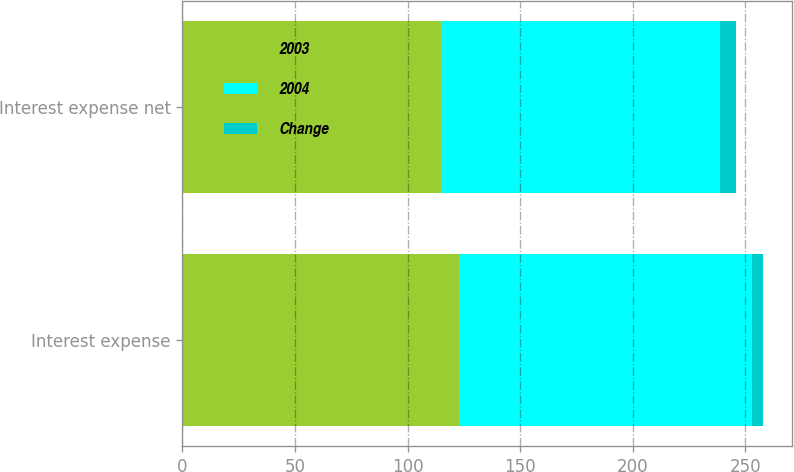Convert chart to OTSL. <chart><loc_0><loc_0><loc_500><loc_500><stacked_bar_chart><ecel><fcel>Interest expense<fcel>Interest expense net<nl><fcel>2003<fcel>123<fcel>115<nl><fcel>2004<fcel>130<fcel>124<nl><fcel>Change<fcel>5<fcel>7<nl></chart> 